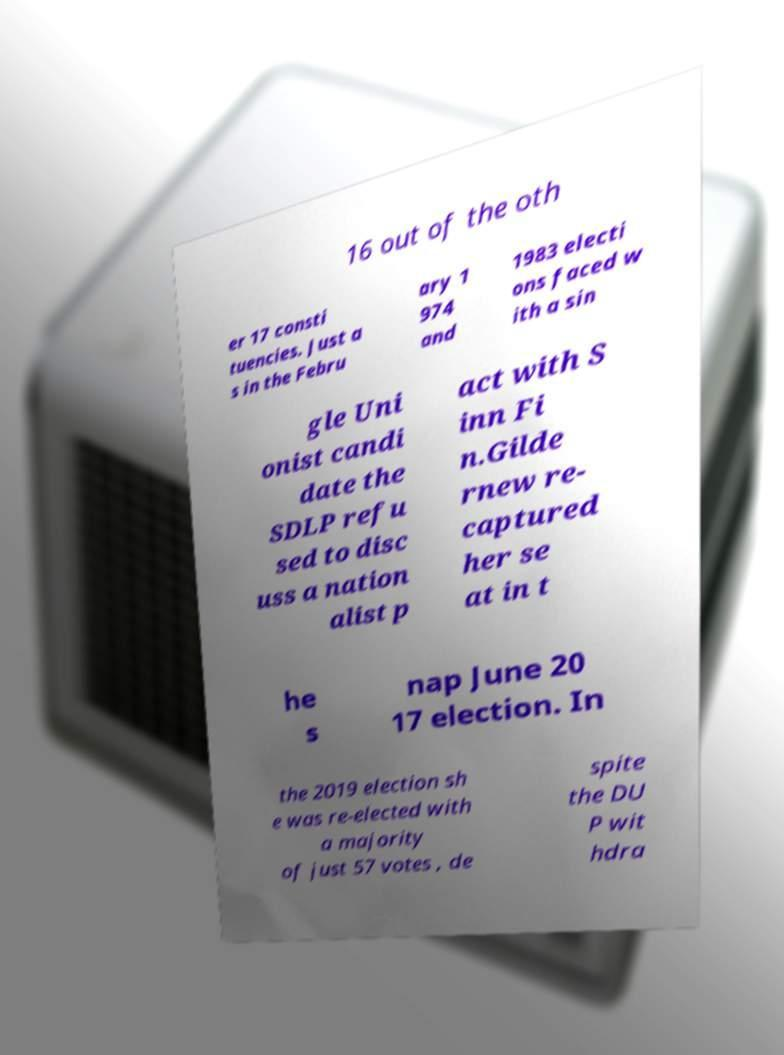Could you assist in decoding the text presented in this image and type it out clearly? 16 out of the oth er 17 consti tuencies. Just a s in the Febru ary 1 974 and 1983 electi ons faced w ith a sin gle Uni onist candi date the SDLP refu sed to disc uss a nation alist p act with S inn Fi n.Gilde rnew re- captured her se at in t he s nap June 20 17 election. In the 2019 election sh e was re-elected with a majority of just 57 votes , de spite the DU P wit hdra 